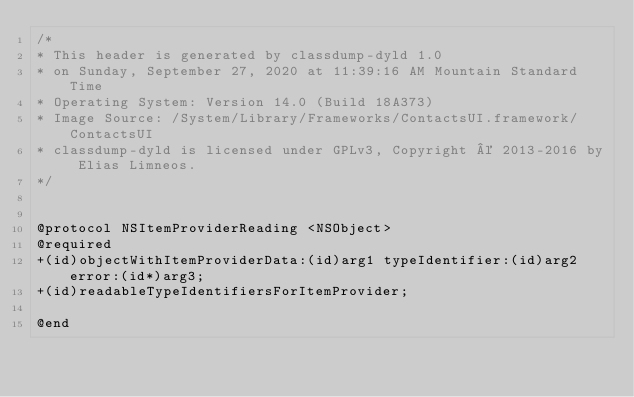<code> <loc_0><loc_0><loc_500><loc_500><_C_>/*
* This header is generated by classdump-dyld 1.0
* on Sunday, September 27, 2020 at 11:39:16 AM Mountain Standard Time
* Operating System: Version 14.0 (Build 18A373)
* Image Source: /System/Library/Frameworks/ContactsUI.framework/ContactsUI
* classdump-dyld is licensed under GPLv3, Copyright © 2013-2016 by Elias Limneos.
*/


@protocol NSItemProviderReading <NSObject>
@required
+(id)objectWithItemProviderData:(id)arg1 typeIdentifier:(id)arg2 error:(id*)arg3;
+(id)readableTypeIdentifiersForItemProvider;

@end

</code> 